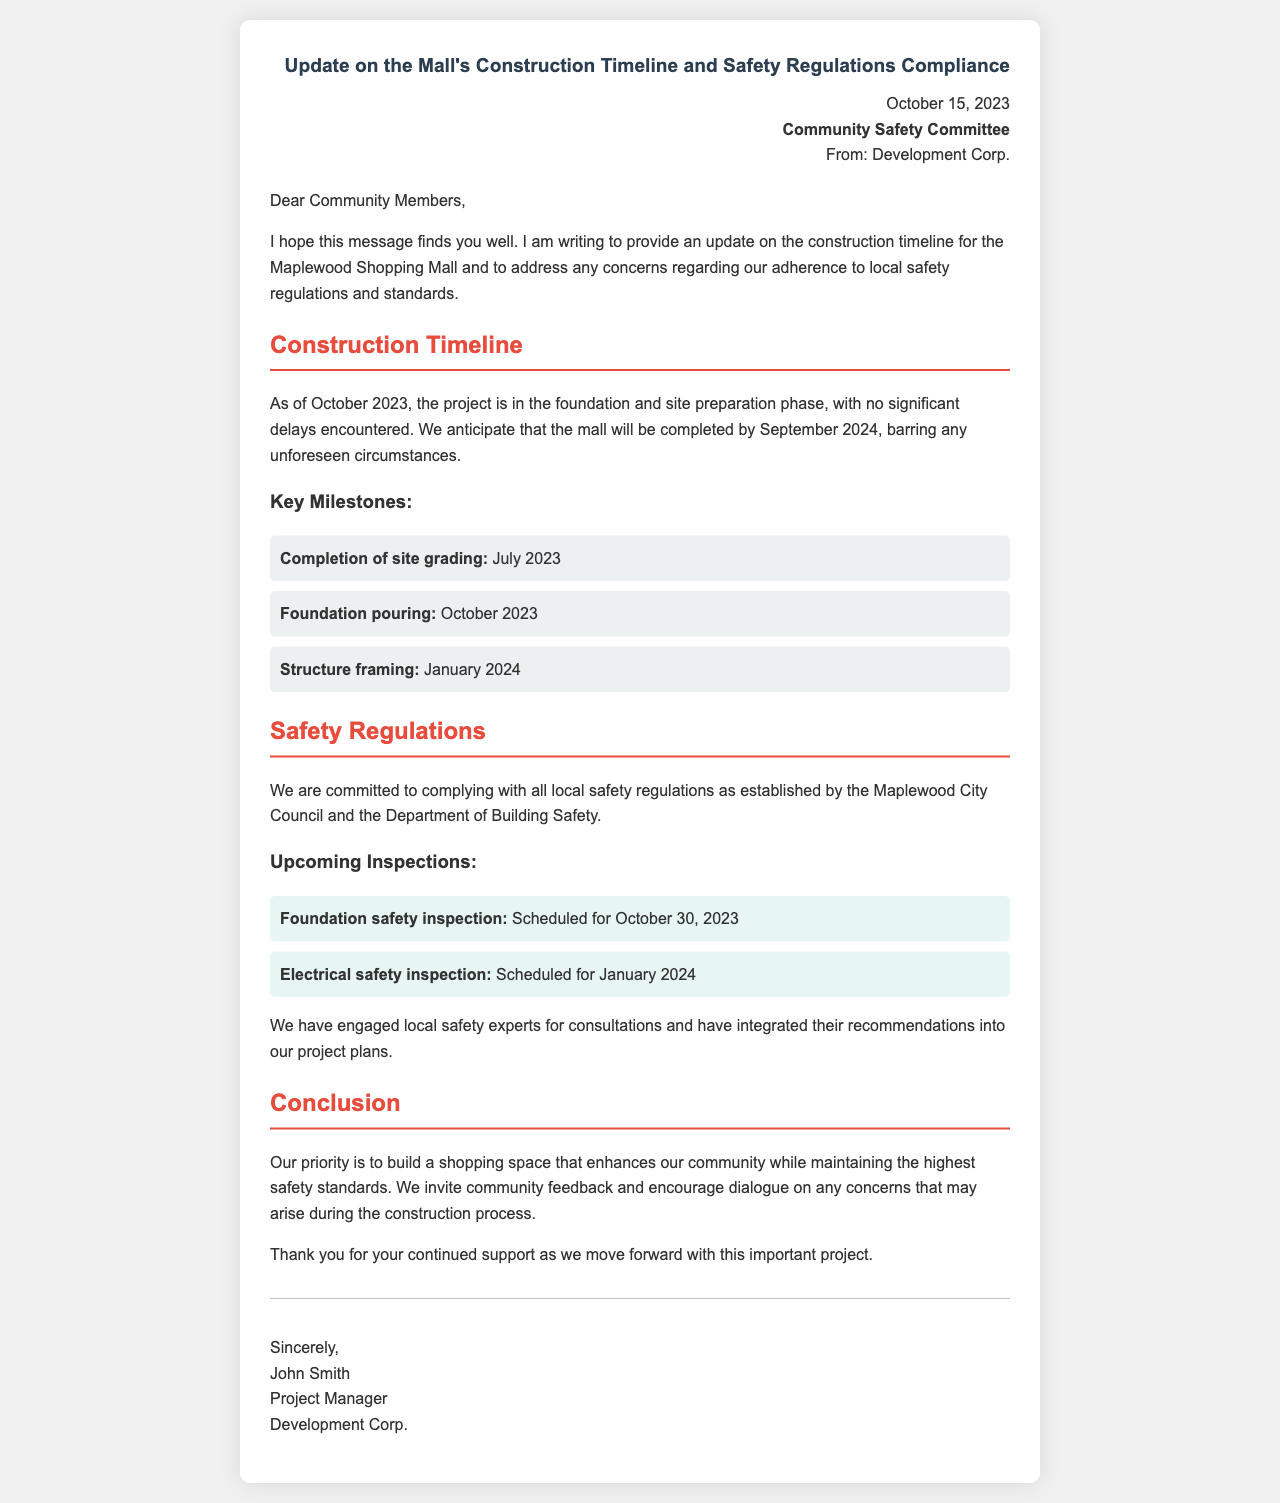What is the completion date for the mall? The document states that the mall is anticipated to be completed by September 2024.
Answer: September 2024 What phase of construction is currently happening? The document mentions that the project is in the foundation and site preparation phase as of October 2023.
Answer: Foundation and site preparation Who is the sender of the letter? The letter is from Development Corp., as indicated in the document.
Answer: Development Corp When is the foundation safety inspection scheduled? The document states that the foundation safety inspection is scheduled for October 30, 2023.
Answer: October 30, 2023 What is the next key milestone after foundation pouring? According to the document, the next key milestone after foundation pouring is structure framing.
Answer: Structure framing Which city's council safety regulations does the project adhere to? The document specifies compliance with safety regulations established by the Maplewood City Council.
Answer: Maplewood City Council What is the project manager's name? The document provides the name of the project manager as John Smith.
Answer: John Smith What has the company engaged for safety consultations? The document states that local safety experts have been engaged for consultations.
Answer: Local safety experts 